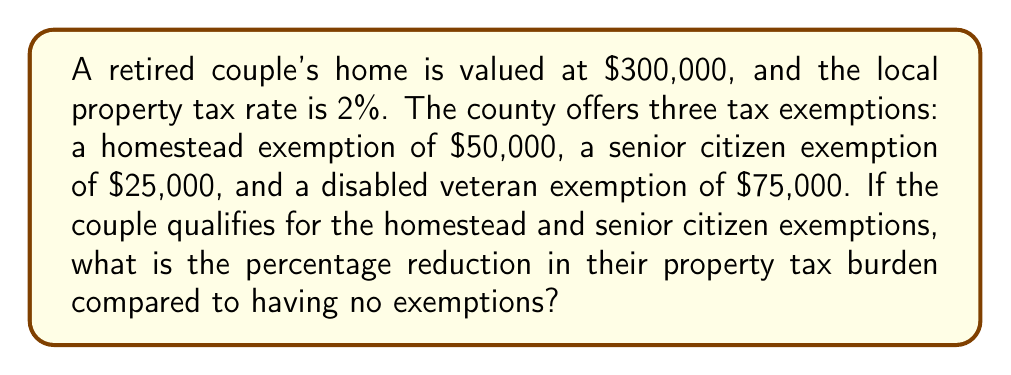Can you answer this question? 1. Calculate the property tax without exemptions:
   $$\text{Tax}_\text{no exemptions} = \$300,000 \times 0.02 = \$6,000$$

2. Calculate the taxable value with exemptions:
   $$\text{Taxable Value} = \$300,000 - \$50,000 - \$25,000 = \$225,000$$

3. Calculate the property tax with exemptions:
   $$\text{Tax}_\text{with exemptions} = \$225,000 \times 0.02 = \$4,500$$

4. Calculate the difference in tax burden:
   $$\text{Tax Reduction} = \$6,000 - \$4,500 = \$1,500$$

5. Calculate the percentage reduction:
   $$\text{Percentage Reduction} = \frac{\$1,500}{\$6,000} \times 100\% = 25\%$$
Answer: 25% 